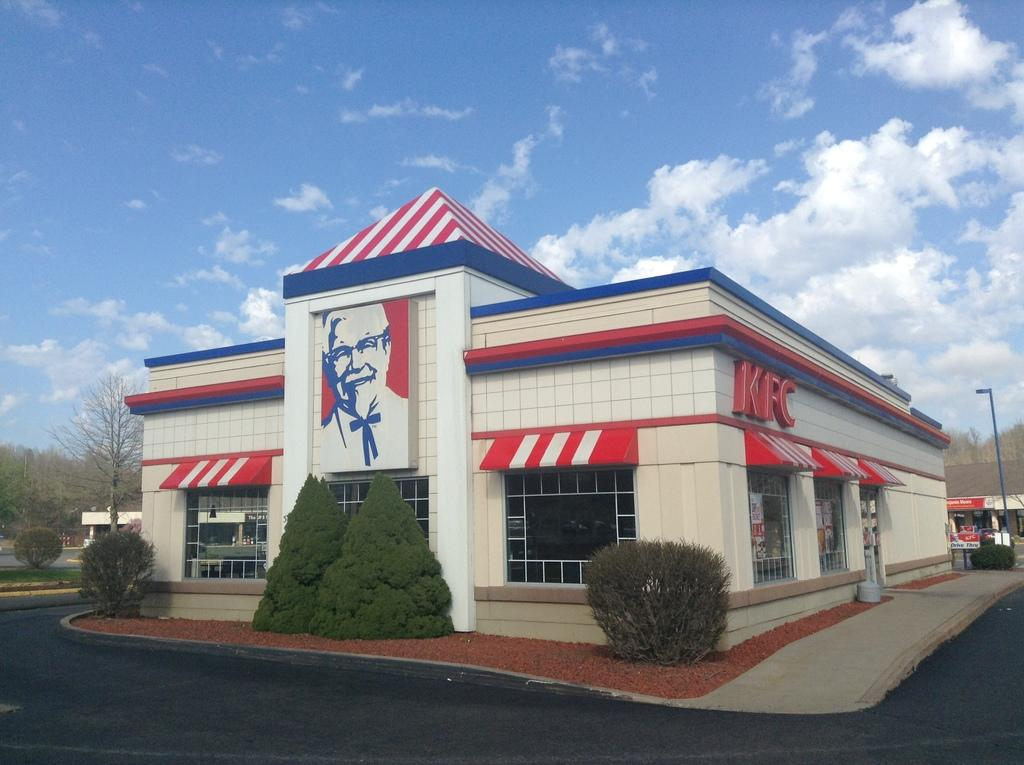What type of surface can be seen in the image? There is a road in the image. What can be found at the bottom of the image? Plants are present at the bottom of the image. What type of vegetation is visible in the image? Trees are visible in the image. What type of structure can be seen in the image? There is a building in the image. What is the condition of the sky in the background? The sky is cloudy in the background. What type of produce is being balanced on the building in the image? There is no produce being balanced on the building in the image; the building is a separate structure from the other elements. 